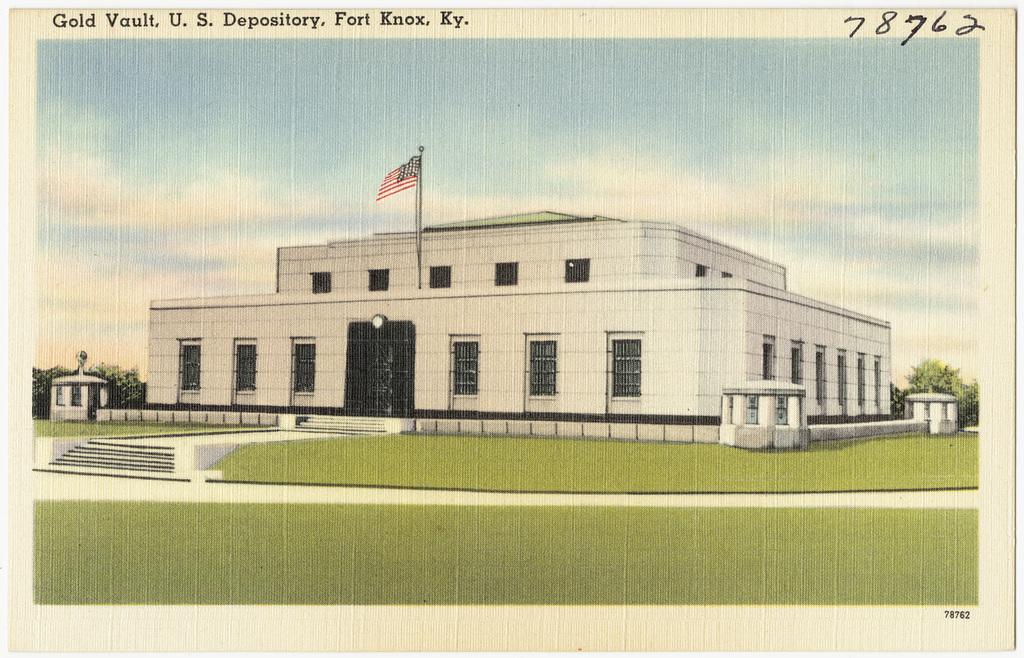In one or two sentences, can you explain what this image depicts? In this image we can see poster of a building which has some doors, windows and in the background of the image there are some trees and clear sky. 